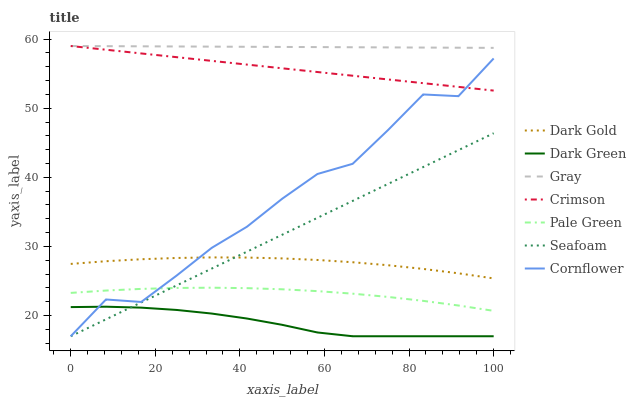Does Dark Gold have the minimum area under the curve?
Answer yes or no. No. Does Dark Gold have the maximum area under the curve?
Answer yes or no. No. Is Dark Gold the smoothest?
Answer yes or no. No. Is Dark Gold the roughest?
Answer yes or no. No. Does Dark Gold have the lowest value?
Answer yes or no. No. Does Dark Gold have the highest value?
Answer yes or no. No. Is Dark Gold less than Crimson?
Answer yes or no. Yes. Is Dark Gold greater than Dark Green?
Answer yes or no. Yes. Does Dark Gold intersect Crimson?
Answer yes or no. No. 